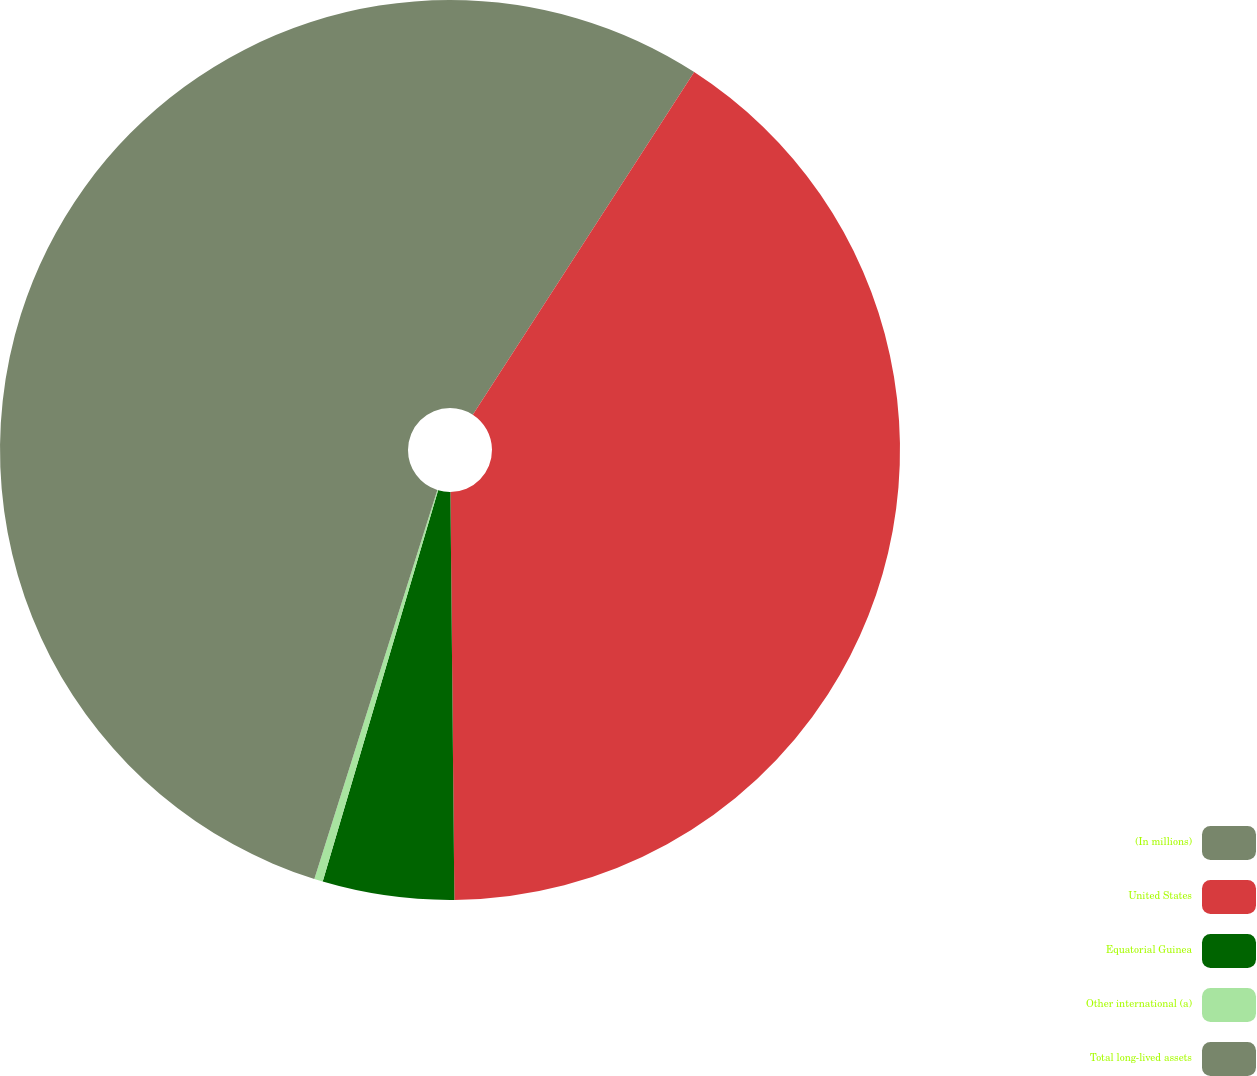Convert chart to OTSL. <chart><loc_0><loc_0><loc_500><loc_500><pie_chart><fcel>(In millions)<fcel>United States<fcel>Equatorial Guinea<fcel>Other international (a)<fcel>Total long-lived assets<nl><fcel>9.13%<fcel>40.72%<fcel>4.72%<fcel>0.31%<fcel>45.13%<nl></chart> 